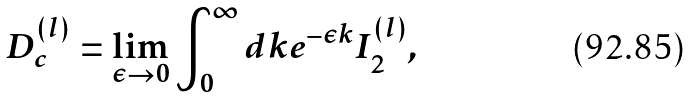<formula> <loc_0><loc_0><loc_500><loc_500>D _ { c } ^ { ( l ) } = \lim _ { \epsilon \rightarrow 0 } \int _ { 0 } ^ { \infty } d k e ^ { - \epsilon k } I _ { 2 } ^ { ( l ) } ,</formula> 